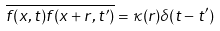Convert formula to latex. <formula><loc_0><loc_0><loc_500><loc_500>\overline { f ( x , t ) f ( x + r , t ^ { \prime } ) } = \kappa ( r ) \delta ( t - t ^ { \prime } )</formula> 